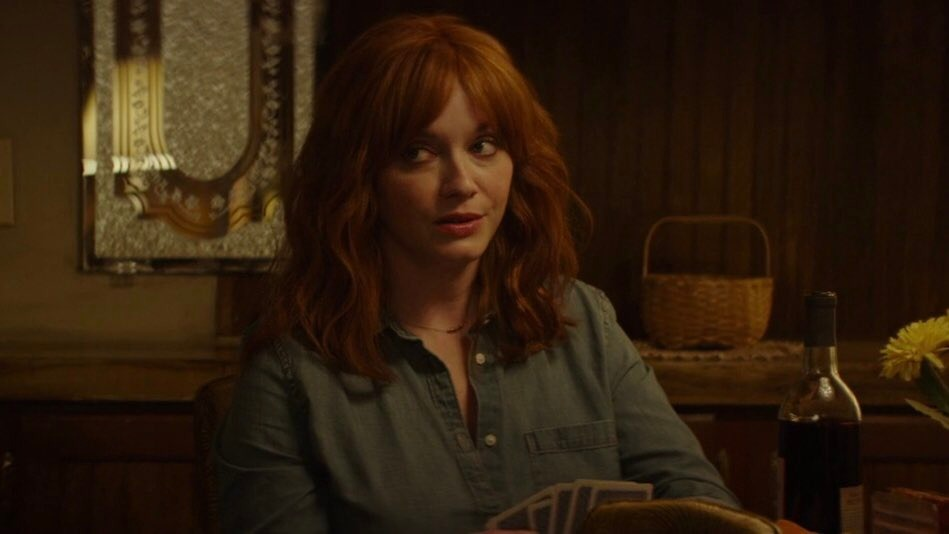Given the items on the table, what might have just happened prior to this moment? It seems like she just concluded a heartfelt conversation over a glass of wine. The bottle and glass suggest a shared moment with someone else who might have just left. Perhaps they discussed important matters or reminisced about old memories, leading to this moment of reflection where she ponders the gravity of their conversation. 